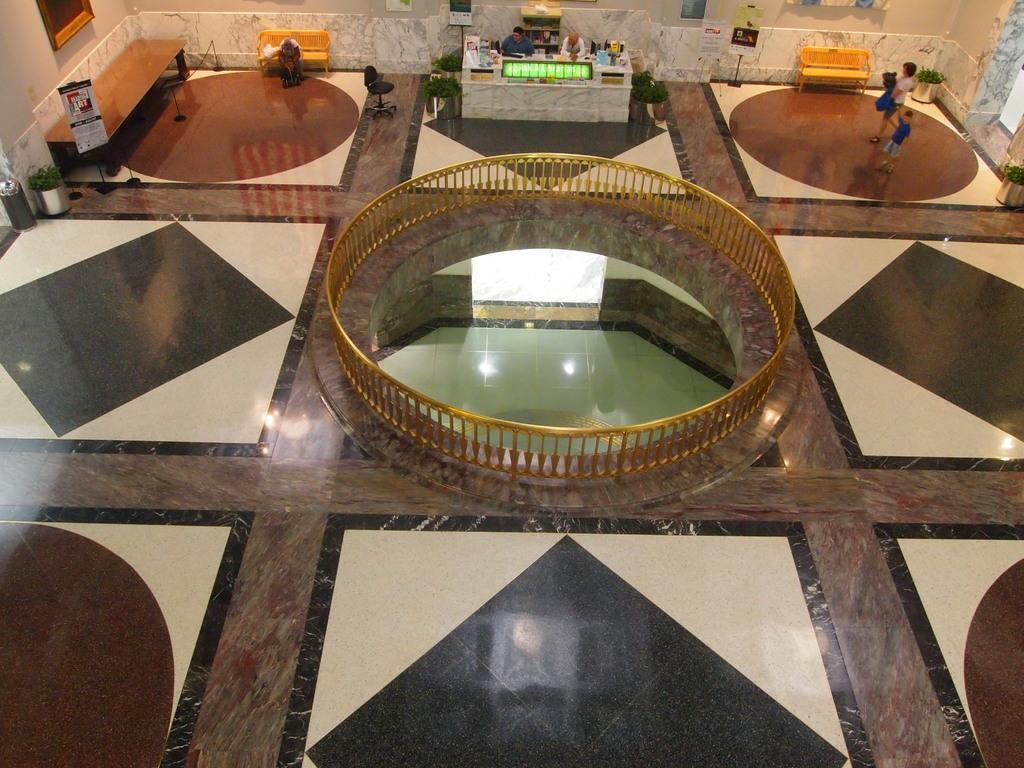Can you describe this image briefly? In this picture we can see the inside view of a hall. This is the floor. And here we can see two persons standing on the floor. These are the benches and this is the table. Here we can see a banner, this is the bin. And there is a plant. Even we can see a person who is sitting on the chair. And this is the wall. 